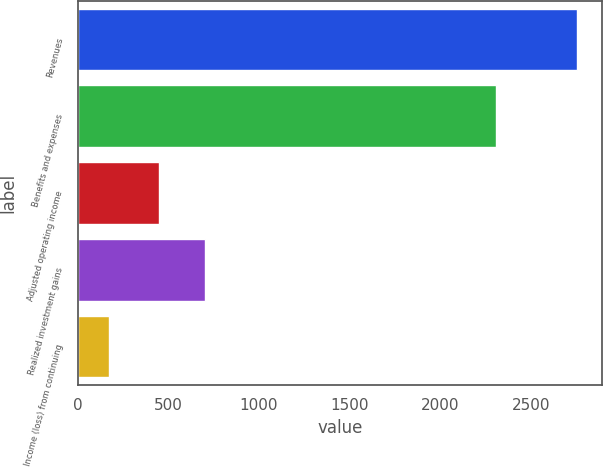<chart> <loc_0><loc_0><loc_500><loc_500><bar_chart><fcel>Revenues<fcel>Benefits and expenses<fcel>Adjusted operating income<fcel>Realized investment gains<fcel>Income (loss) from continuing<nl><fcel>2754<fcel>2308<fcel>446<fcel>704.1<fcel>173<nl></chart> 